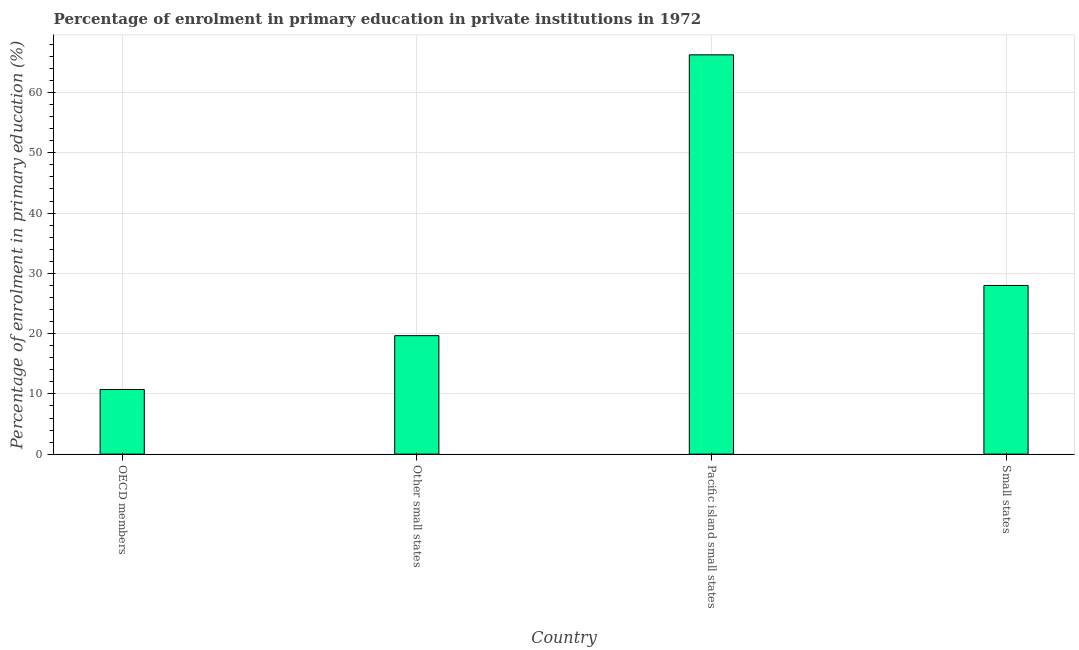Does the graph contain grids?
Your response must be concise. Yes. What is the title of the graph?
Offer a very short reply. Percentage of enrolment in primary education in private institutions in 1972. What is the label or title of the Y-axis?
Make the answer very short. Percentage of enrolment in primary education (%). What is the enrolment percentage in primary education in Pacific island small states?
Ensure brevity in your answer.  66.26. Across all countries, what is the maximum enrolment percentage in primary education?
Ensure brevity in your answer.  66.26. Across all countries, what is the minimum enrolment percentage in primary education?
Keep it short and to the point. 10.73. In which country was the enrolment percentage in primary education maximum?
Give a very brief answer. Pacific island small states. In which country was the enrolment percentage in primary education minimum?
Provide a succinct answer. OECD members. What is the sum of the enrolment percentage in primary education?
Ensure brevity in your answer.  124.65. What is the difference between the enrolment percentage in primary education in OECD members and Pacific island small states?
Ensure brevity in your answer.  -55.53. What is the average enrolment percentage in primary education per country?
Keep it short and to the point. 31.16. What is the median enrolment percentage in primary education?
Provide a succinct answer. 23.83. What is the ratio of the enrolment percentage in primary education in OECD members to that in Pacific island small states?
Your answer should be very brief. 0.16. Is the difference between the enrolment percentage in primary education in OECD members and Pacific island small states greater than the difference between any two countries?
Ensure brevity in your answer.  Yes. What is the difference between the highest and the second highest enrolment percentage in primary education?
Your answer should be compact. 38.26. What is the difference between the highest and the lowest enrolment percentage in primary education?
Your response must be concise. 55.53. In how many countries, is the enrolment percentage in primary education greater than the average enrolment percentage in primary education taken over all countries?
Offer a very short reply. 1. How many bars are there?
Ensure brevity in your answer.  4. What is the difference between two consecutive major ticks on the Y-axis?
Keep it short and to the point. 10. Are the values on the major ticks of Y-axis written in scientific E-notation?
Your answer should be very brief. No. What is the Percentage of enrolment in primary education (%) of OECD members?
Provide a short and direct response. 10.73. What is the Percentage of enrolment in primary education (%) of Other small states?
Your answer should be very brief. 19.66. What is the Percentage of enrolment in primary education (%) in Pacific island small states?
Provide a succinct answer. 66.26. What is the Percentage of enrolment in primary education (%) of Small states?
Make the answer very short. 28. What is the difference between the Percentage of enrolment in primary education (%) in OECD members and Other small states?
Offer a terse response. -8.93. What is the difference between the Percentage of enrolment in primary education (%) in OECD members and Pacific island small states?
Offer a very short reply. -55.53. What is the difference between the Percentage of enrolment in primary education (%) in OECD members and Small states?
Give a very brief answer. -17.26. What is the difference between the Percentage of enrolment in primary education (%) in Other small states and Pacific island small states?
Keep it short and to the point. -46.6. What is the difference between the Percentage of enrolment in primary education (%) in Other small states and Small states?
Your response must be concise. -8.33. What is the difference between the Percentage of enrolment in primary education (%) in Pacific island small states and Small states?
Your response must be concise. 38.26. What is the ratio of the Percentage of enrolment in primary education (%) in OECD members to that in Other small states?
Provide a succinct answer. 0.55. What is the ratio of the Percentage of enrolment in primary education (%) in OECD members to that in Pacific island small states?
Give a very brief answer. 0.16. What is the ratio of the Percentage of enrolment in primary education (%) in OECD members to that in Small states?
Your answer should be compact. 0.38. What is the ratio of the Percentage of enrolment in primary education (%) in Other small states to that in Pacific island small states?
Your response must be concise. 0.3. What is the ratio of the Percentage of enrolment in primary education (%) in Other small states to that in Small states?
Provide a succinct answer. 0.7. What is the ratio of the Percentage of enrolment in primary education (%) in Pacific island small states to that in Small states?
Provide a short and direct response. 2.37. 